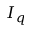<formula> <loc_0><loc_0><loc_500><loc_500>I _ { q }</formula> 